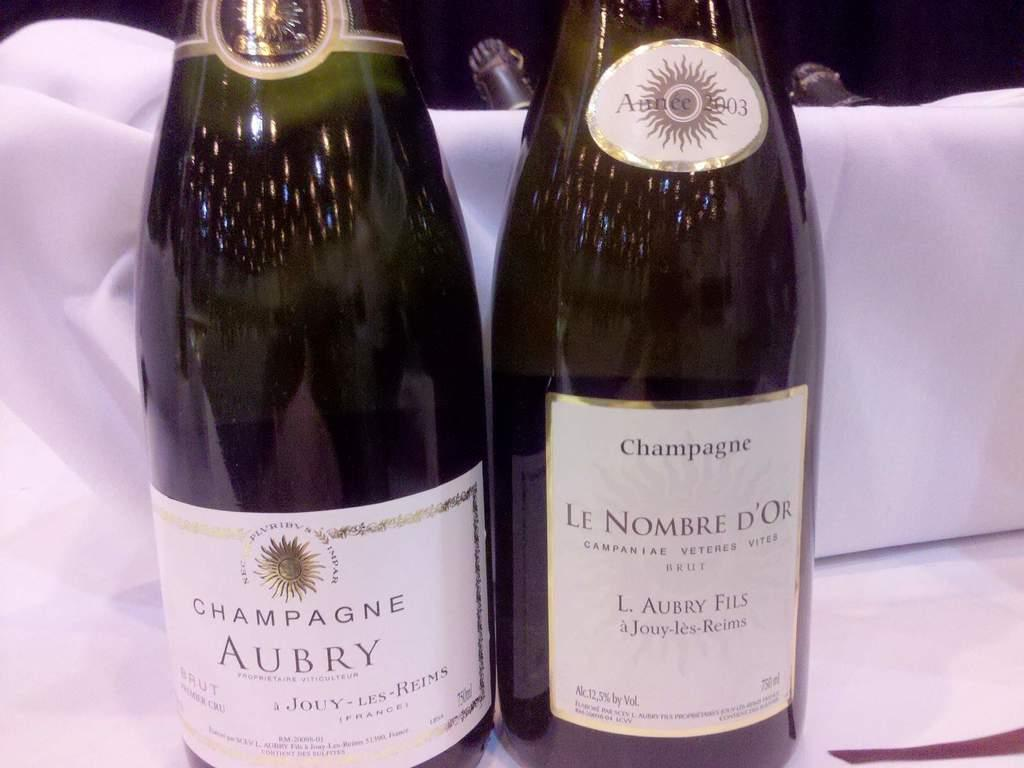<image>
Offer a succinct explanation of the picture presented. A bottle of Aubry and Le Nombre Champagne sit on the table. 